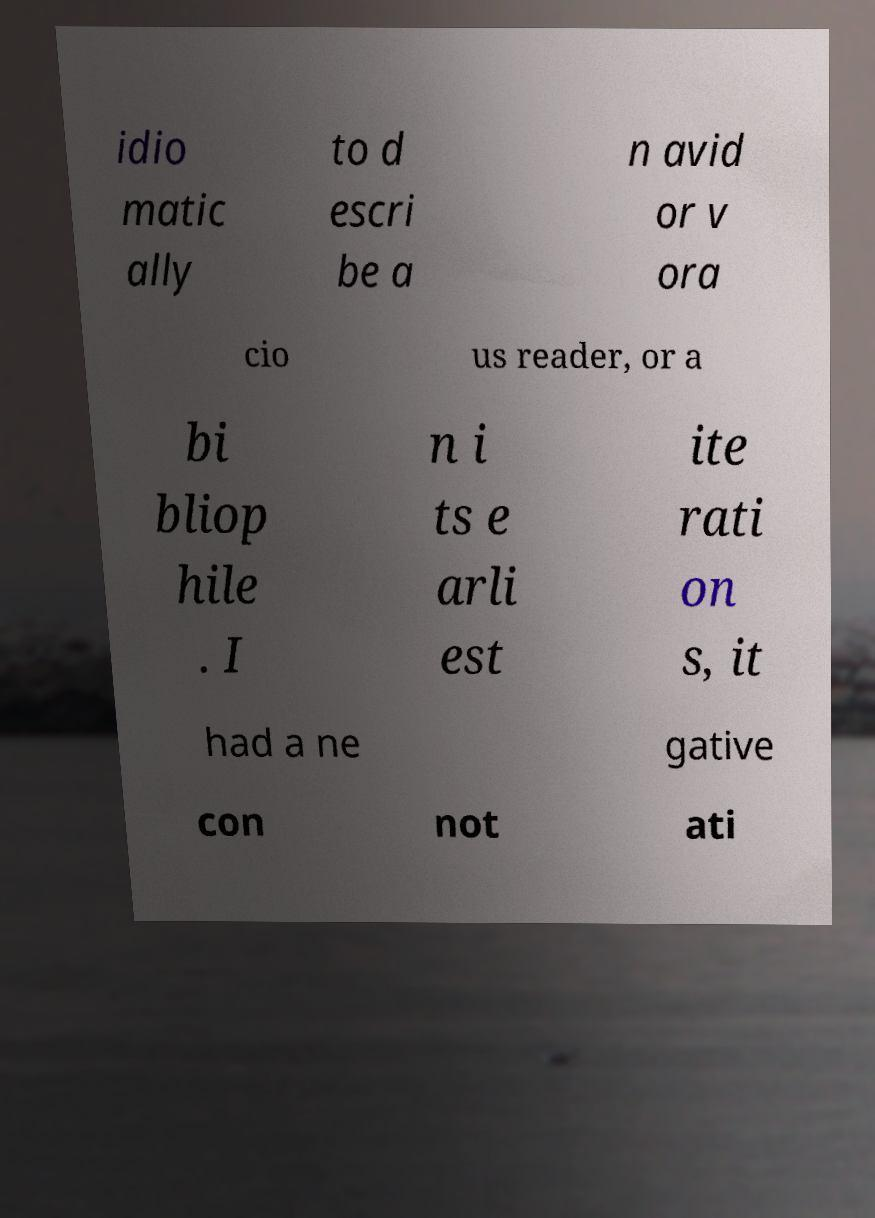Can you accurately transcribe the text from the provided image for me? idio matic ally to d escri be a n avid or v ora cio us reader, or a bi bliop hile . I n i ts e arli est ite rati on s, it had a ne gative con not ati 